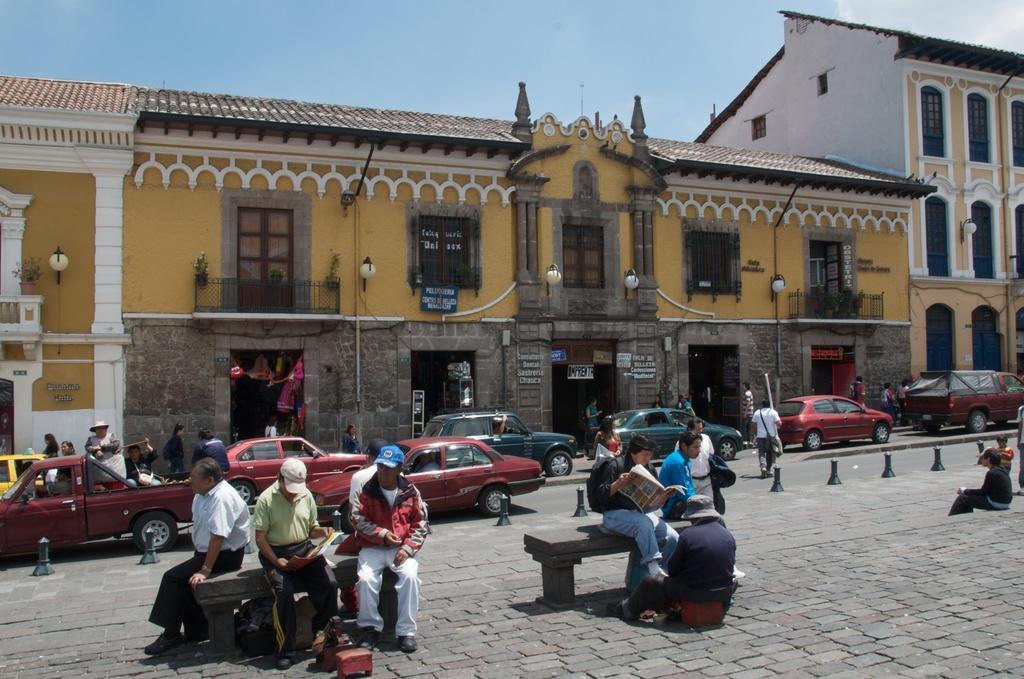Please provide a concise description of this image. In the middle of the image few people are sitting on benches. Behind them there are some vehicles on the road and few people are walking. Top of the image there are some buildings and lights. Behind them there are some clouds and sky. 